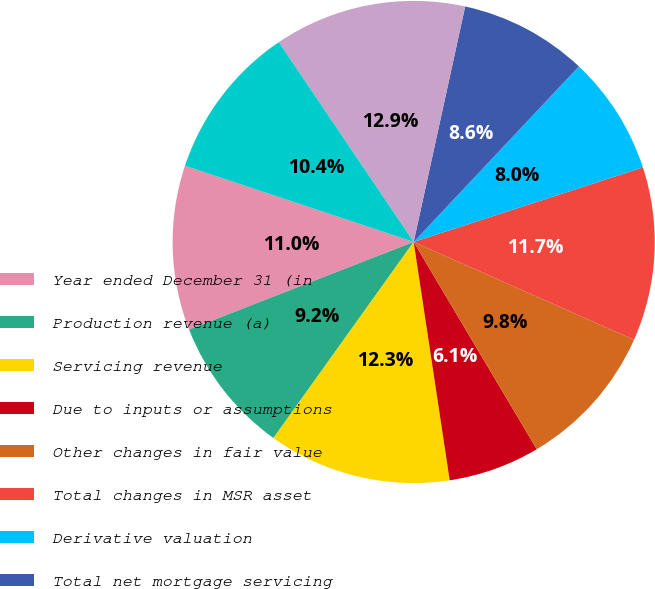<chart> <loc_0><loc_0><loc_500><loc_500><pie_chart><fcel>Year ended December 31 (in<fcel>Production revenue (a)<fcel>Servicing revenue<fcel>Due to inputs or assumptions<fcel>Other changes in fair value<fcel>Total changes in MSR asset<fcel>Derivative valuation<fcel>Total net mortgage servicing<fcel>Total net revenue<fcel>Noninterest expense (a)<nl><fcel>11.04%<fcel>9.2%<fcel>12.27%<fcel>6.14%<fcel>9.82%<fcel>11.66%<fcel>7.98%<fcel>8.59%<fcel>12.88%<fcel>10.43%<nl></chart> 